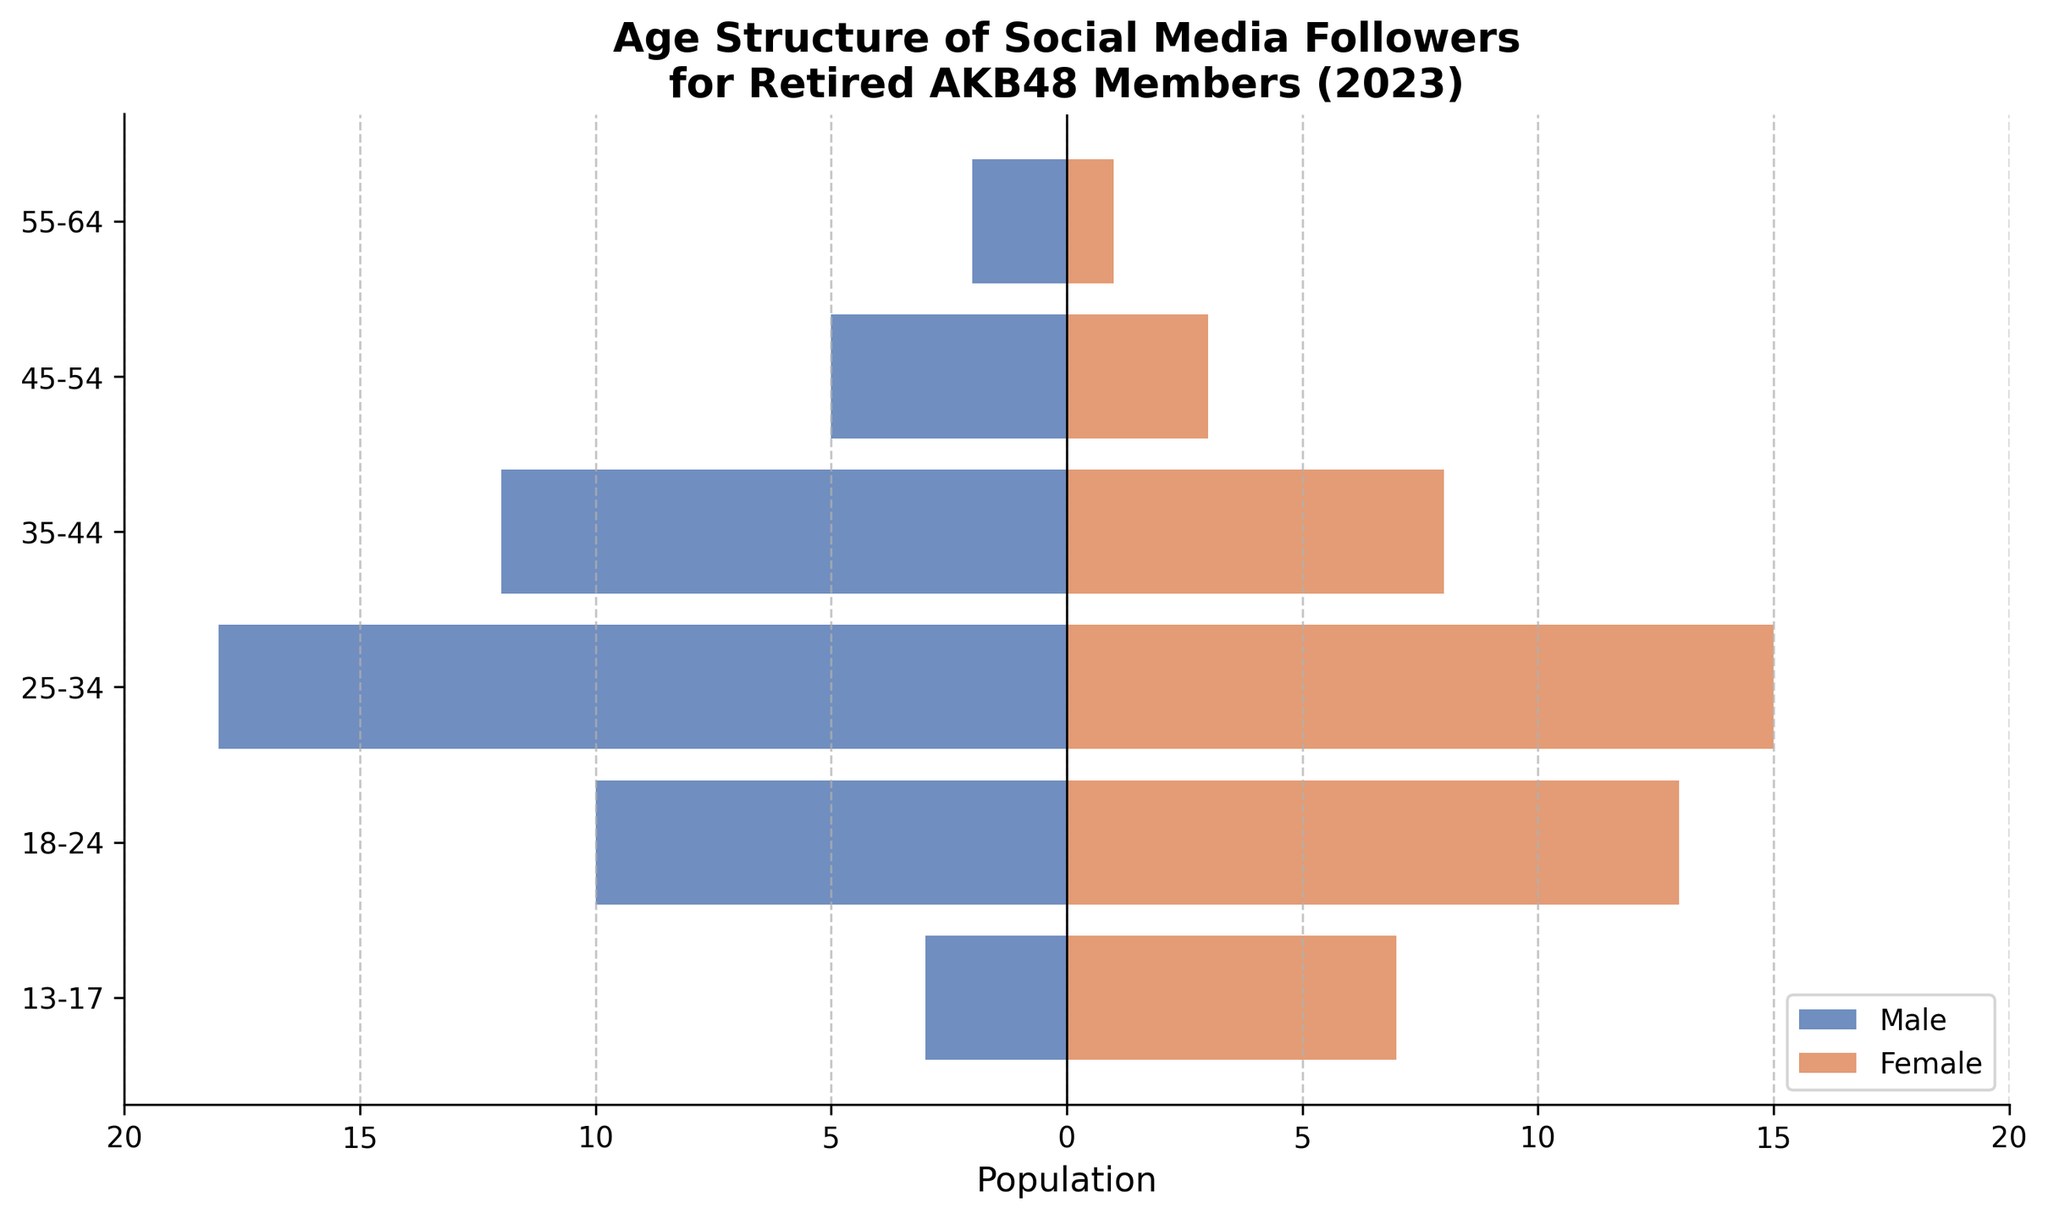What's the title of the figure? The title is usually placed at the top of the figure and describes the content. In this case, it reads "Age Structure of Social Media Followers for Retired AKB48 Members (2023)".
Answer: Age Structure of Social Media Followers for Retired AKB48 Members (2023) Which age group has the highest number of male followers? Look at the bar extending to the left for male followers and identify the longest one. The longest bar is in the 25-34 age group.
Answer: 25-34 How many total female followers are in the 18-24 and 25-34 age groups combined? Add the female values for these two age groups from the figure. 13 (18-24) + 15 (25-34) = 28
Answer: 28 What is the difference in the number of male followers between the 35-44 and 45-54 age groups? Subtract the value of male followers in the 45-54 age group from the 35-44 age group. 12 (35-44) - 5 (45-54) = 7
Answer: 7 Which age group has more female followers than male followers? Compare the lengths of the bars for both males and females across age groups. The 13-17 and 18-24 age groups have more female followers than male.
Answer: 13-17 and 18-24 How does the number of female followers in the 13-17 age group compare to the 55-64 age group? Compare the lengths of the bars for females in these two age groups and see that 13-17 age group has more.
Answer: Females in 13-17 > 55-64 What's the total number of male followers across all age groups? Add the male followers for each age group from the figure. 2 (55-64) + 5 (45-54) + 12 (35-44) + 18 (25-34) + 10 (18-24) + 3 (13-17) = 50
Answer: 50 What is the overall trend in the number of followers from the youngest to the oldest age group? Observe the bars' lengths across age groups from the bottom to the top to determine the trend. The number of followers generally decreases as the age increases except for a spike in 25-34.
Answer: Decreasing trend Are there more female followers in the 25-34 age group than the combined total of male and female followers in the 13-17 age group? Compare 15 (females in 25-34) with the sum 10 (3 males + 7 females in 13-17). 15 > 10.
Answer: Yes 